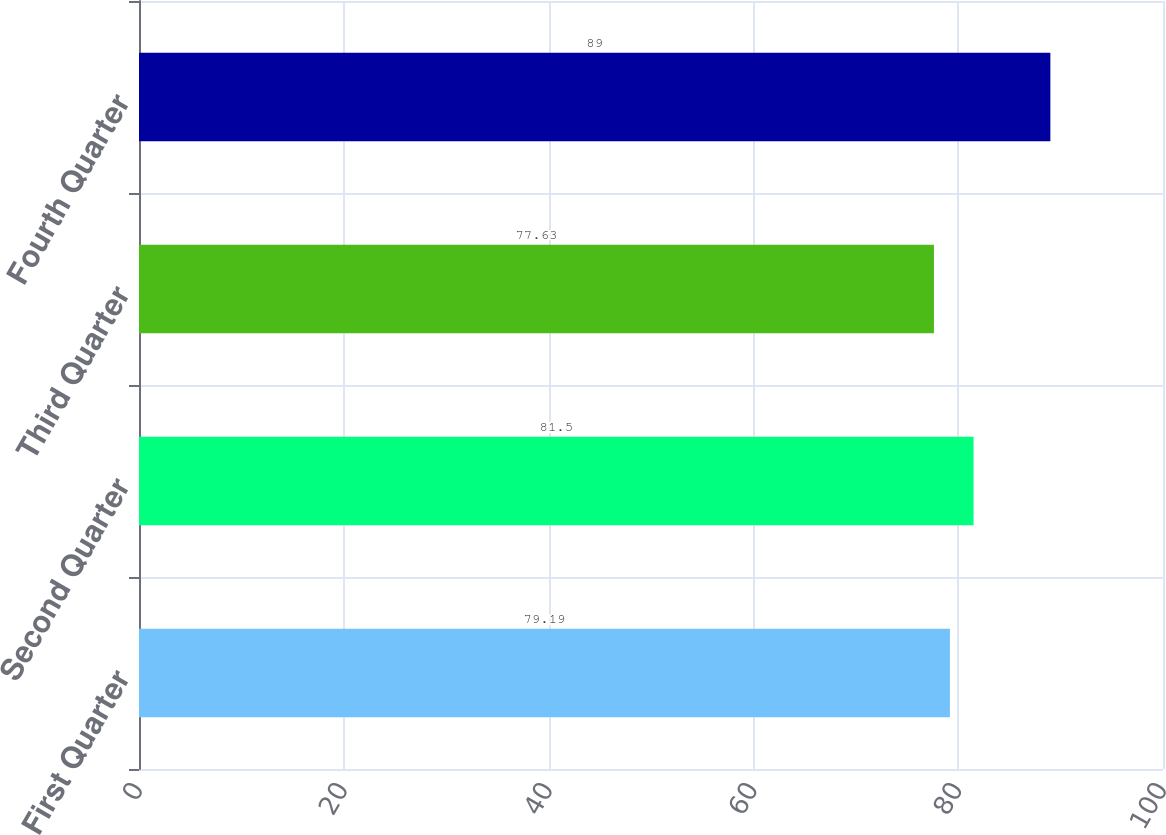Convert chart to OTSL. <chart><loc_0><loc_0><loc_500><loc_500><bar_chart><fcel>First Quarter<fcel>Second Quarter<fcel>Third Quarter<fcel>Fourth Quarter<nl><fcel>79.19<fcel>81.5<fcel>77.63<fcel>89<nl></chart> 